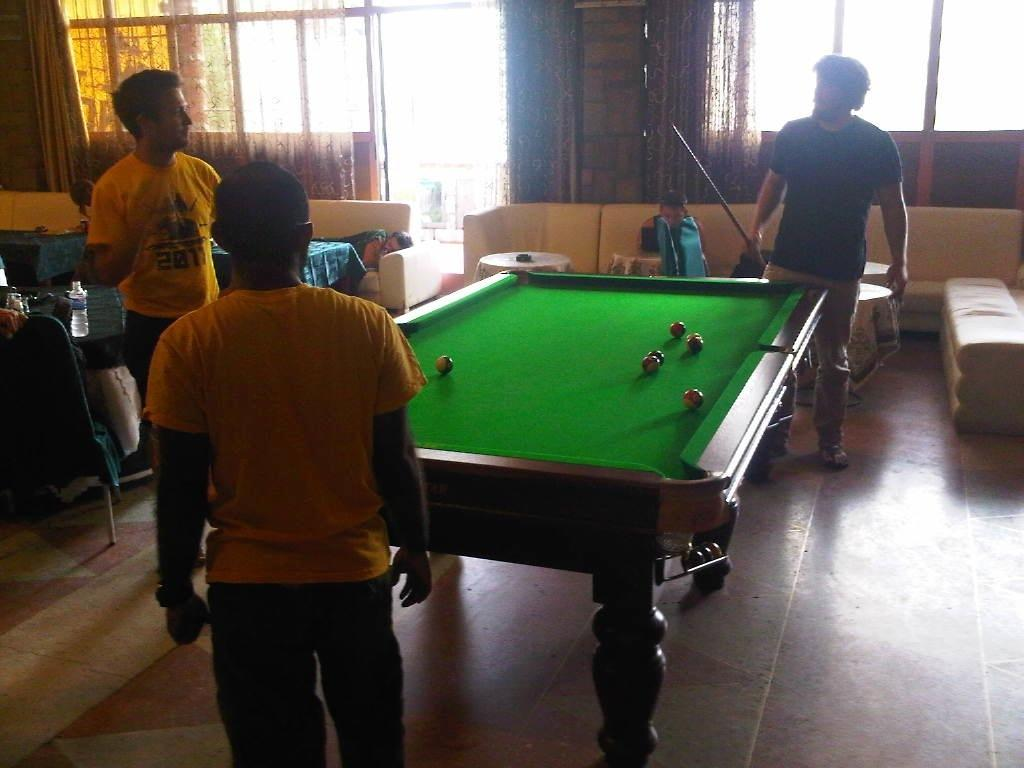What activity are the three people in the image engaged in? The three people in the image are playing snooker. Can you describe the setting where the snooker game is taking place? There are people sitting in a sofa in the background of the image. What type of song is being played on the drawer in the image? There is no drawer or song present in the image; it features three people playing snooker and people sitting on a sofa in the background. 